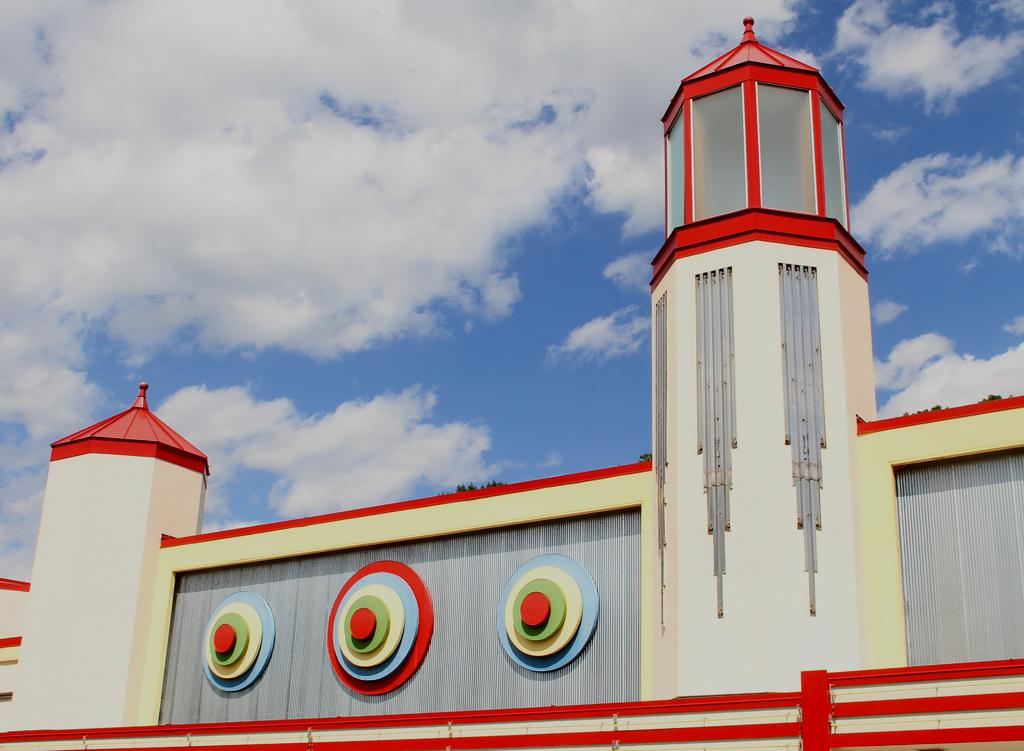What type of structure is visible in the image? There is a building in the image. What other natural elements can be seen in the image? There are trees in the image. What is visible in the background of the image? The sky is visible in the image. What can be observed in the sky? Clouds are present in the sky. What type of amusement can be seen in the image? There is no amusement present in the image; it features a building, trees, and a sky with clouds. Can you tell me where the net is located in the image? There is no net present in the image. 